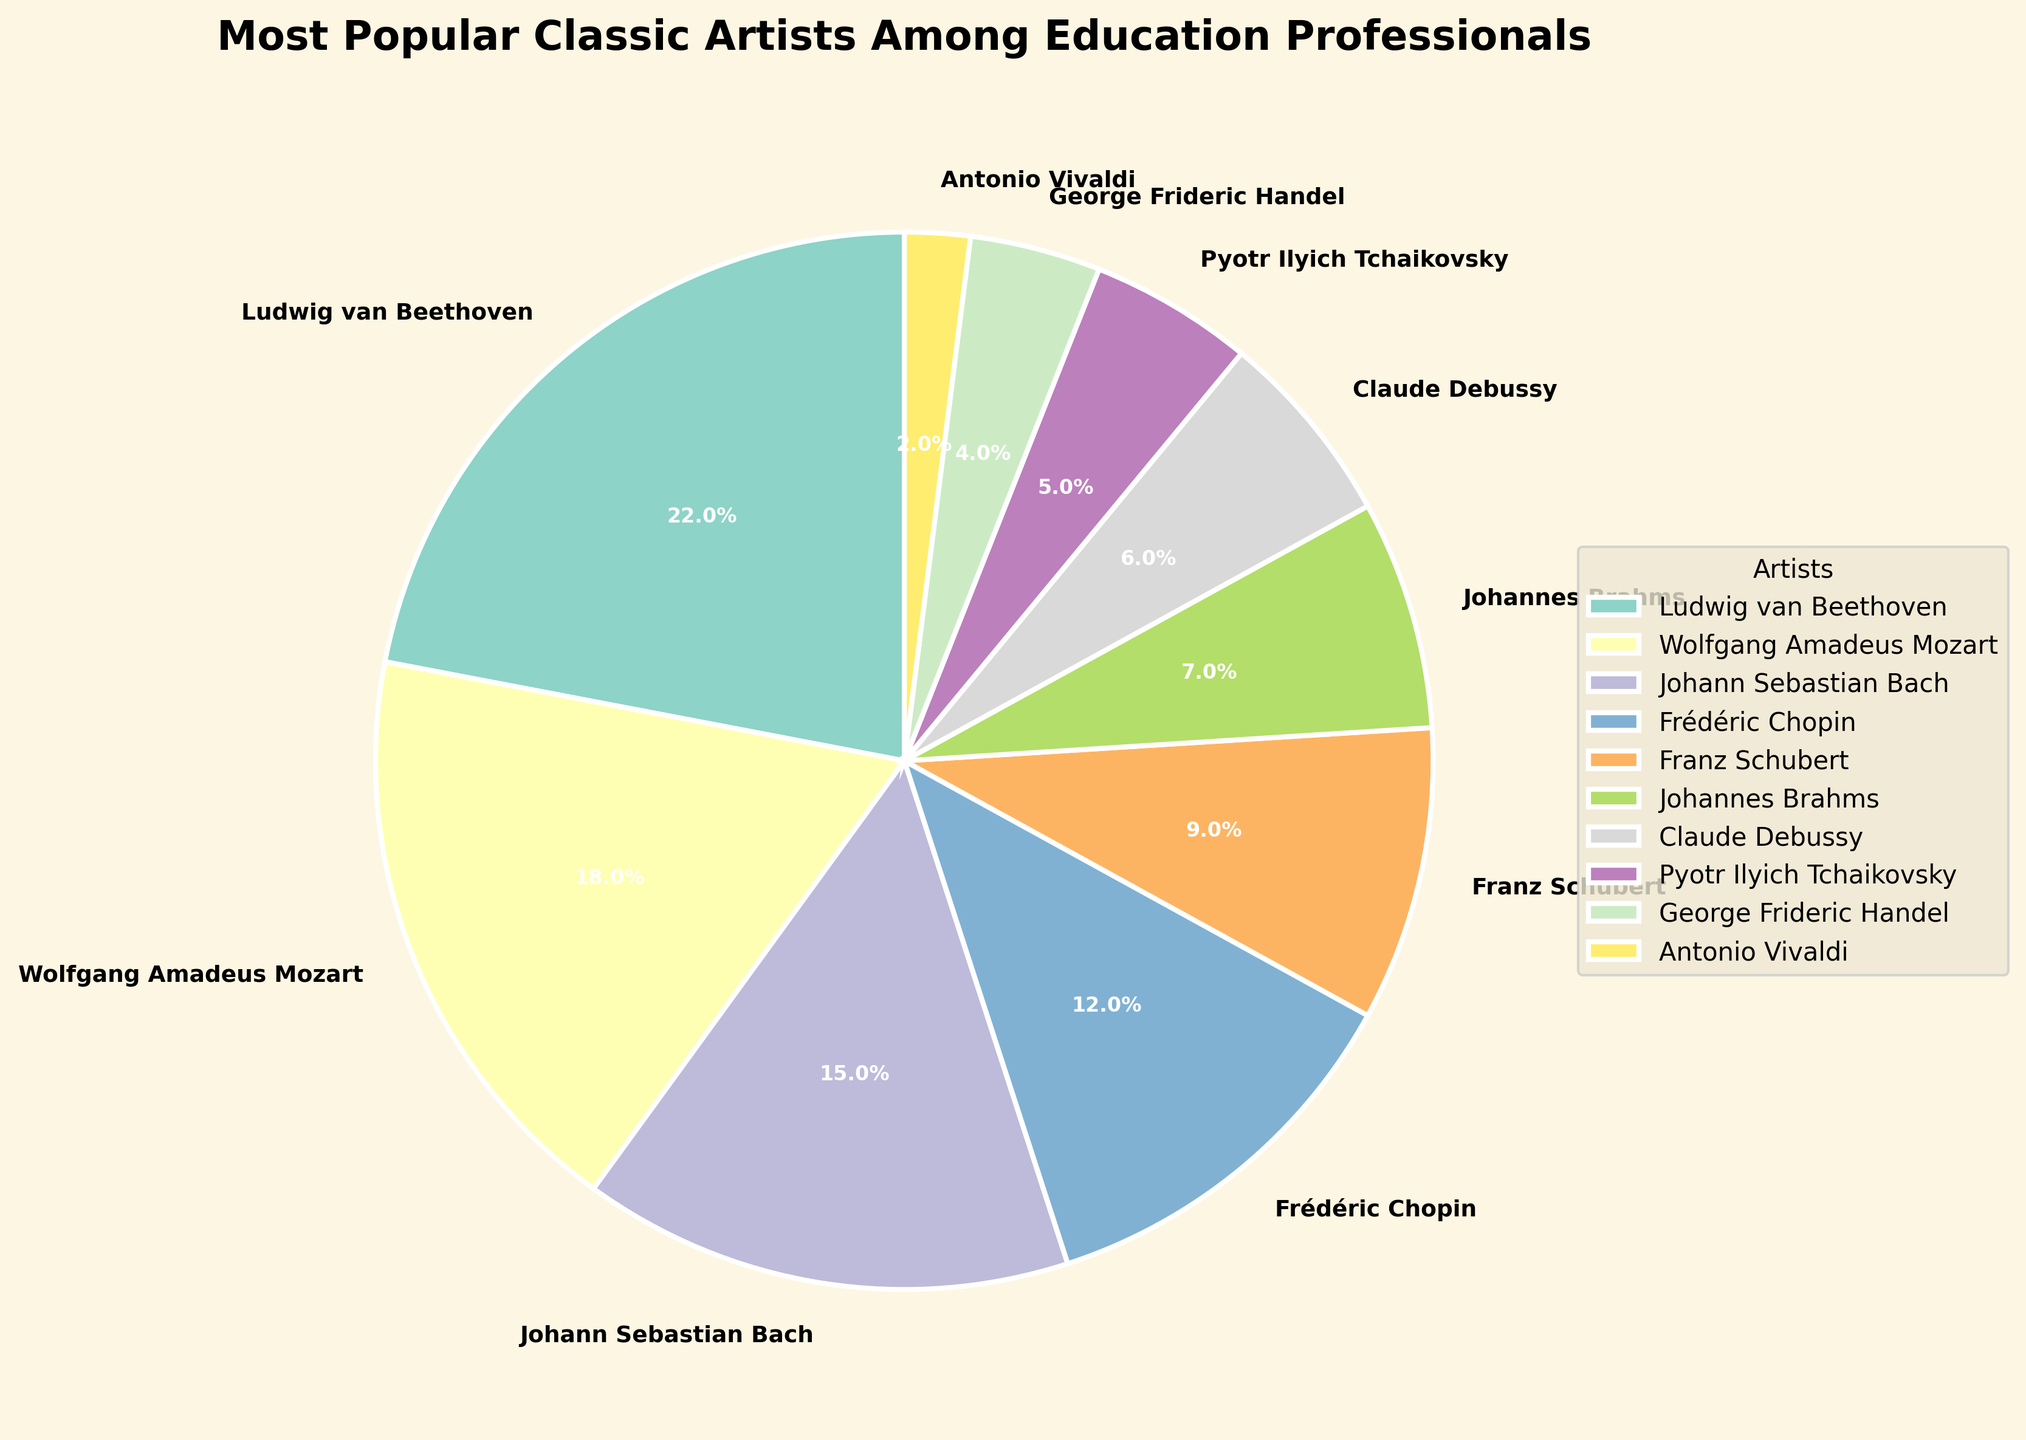What's the most popular classic artist among education professionals? The largest wedge in the pie chart represents the artist with the highest percentage, which is Ludwig van Beethoven with 22%.
Answer: Ludwig van Beethoven Which artist is more popular: Claude Debussy or Pyotr Ilyich Tchaikovsky? Compare the wedge sizes and the percentages labeled on the chart for both artists. Claude Debussy has 6%, while Pyotr Ilyich Tchaikovsky has 5%.
Answer: Claude Debussy What is the combined percentage of Johann Sebastian Bach and Frédéric Chopin? Add the percentages of Johann Sebastian Bach (15%) and Frédéric Chopin (12%). 15% + 12% = 27%.
Answer: 27% Are there more artists that are more or less popular than Wolfgang Amadeus Mozart? Check the count of artists with percentages greater and less than Mozart’s 18%. There are 1 artist with a greater percentage (Beethoven) and 8 with less.
Answer: Less How much more popular is Ludwig van Beethoven compared to Johannes Brahms? Subtract Johannes Brahms's percentage (7%) from Ludwig van Beethoven's (22%). 22% - 7% = 15%.
Answer: 15% Arrange the artists with percentages from highest to lowest? List the artists in descending order of their labeled percentages: Ludwig van Beethoven (22%), Wolfgang Amadeus Mozart (18%), Johann Sebastian Bach (15%), Frédéric Chopin (12%), Franz Schubert (9%), Johannes Brahms (7%), Claude Debussy (6%), Pyotr Ilyich Tchaikovsky (5%), George Frideric Handel (4%), Antonio Vivaldi (2%).
Answer: Ludwig van Beethoven, Wolfgang Amadeus Mozart, Johann Sebastian Bach, Frédéric Chopin, Franz Schubert, Johannes Brahms, Claude Debussy, Pyotr Ilyich Tchaikovsky, George Frideric Handel, Antonio Vivaldi By how much does the popularity of Wolfgang Amadeus Mozart exceed that of Franz Schubert? Subtract Franz Schubert's percentage (9%) from Wolfgang Amadeus Mozart's (18%). 18% - 9% = 9%.
Answer: 9% What colors represent the artists with percentages 4% and 2% respectively? Identify the wedges corresponding to 4% and 2%, which represent George Frideric Handel and Antonio Vivaldi respectively. The colors may vary, but mention their relative position if prompted during the chart viewing.
Answer: Varies (specify color positions if prompted) Which artists cumulatively contribute to less than 20% popularity? Sum the percentages of artists from the smallest upwards until the total is less than 20%. Antonio Vivaldi (2%), George Frideric Handel (4%), Pyotr Ilyich Tchaikovsky (5%), and Claude Debussy (6%) together make 17% which is less than 20%.
Answer: Antonio Vivaldi, George Frideric Handel, Pyotr Ilyich Tchaikovsky, Claude Debussy 